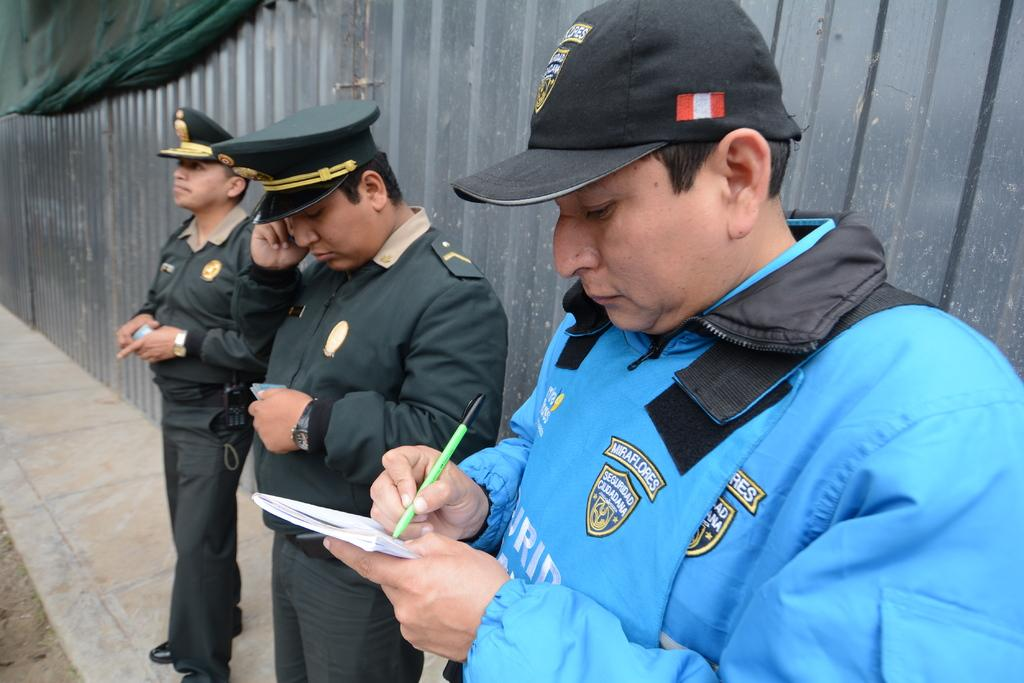How many officers are present in the image? There are three officers in the image. What is the background of the image? The officers are standing in front of a fence made with metal. What is the first person doing in the image? The first person is writing something in a book. What type of fish can be seen swimming near the officers in the image? There are no fish present in the image; it features three officers standing in front of a metal fence. 